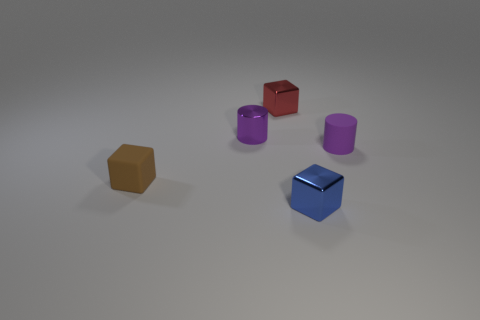What number of other things are made of the same material as the brown object?
Keep it short and to the point. 1. Are there an equal number of blue blocks that are to the left of the blue cube and tiny brown things that are to the left of the small red thing?
Provide a short and direct response. No. How many blue objects are tiny objects or blocks?
Make the answer very short. 1. There is a tiny metal cylinder; does it have the same color as the small object that is to the right of the tiny blue metal block?
Your answer should be compact. Yes. What number of other objects are the same color as the matte cylinder?
Offer a very short reply. 1. Are there fewer blue metal blocks than tiny gray cylinders?
Provide a succinct answer. No. How many tiny cylinders are on the right side of the small shiny cube that is to the left of the small shiny block that is in front of the red object?
Keep it short and to the point. 1. Do the tiny rubber object that is to the right of the matte block and the small purple metal thing have the same shape?
Ensure brevity in your answer.  Yes. There is a red thing that is the same shape as the tiny brown object; what is its material?
Make the answer very short. Metal. Is there any other thing that has the same size as the red block?
Give a very brief answer. Yes. 